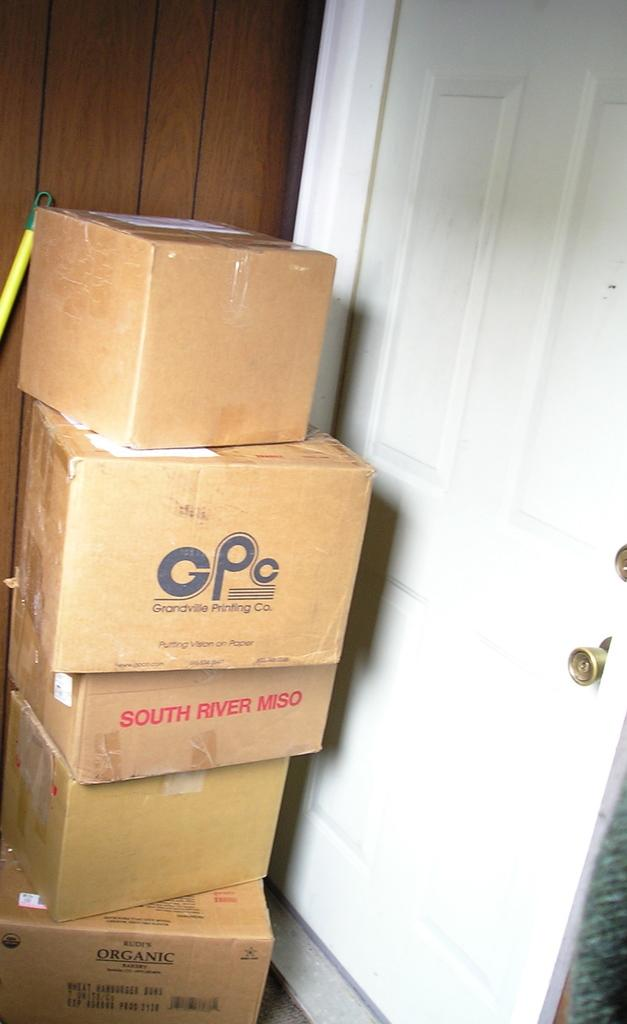<image>
Offer a succinct explanation of the picture presented. The bottom box advertses organic products within it. 